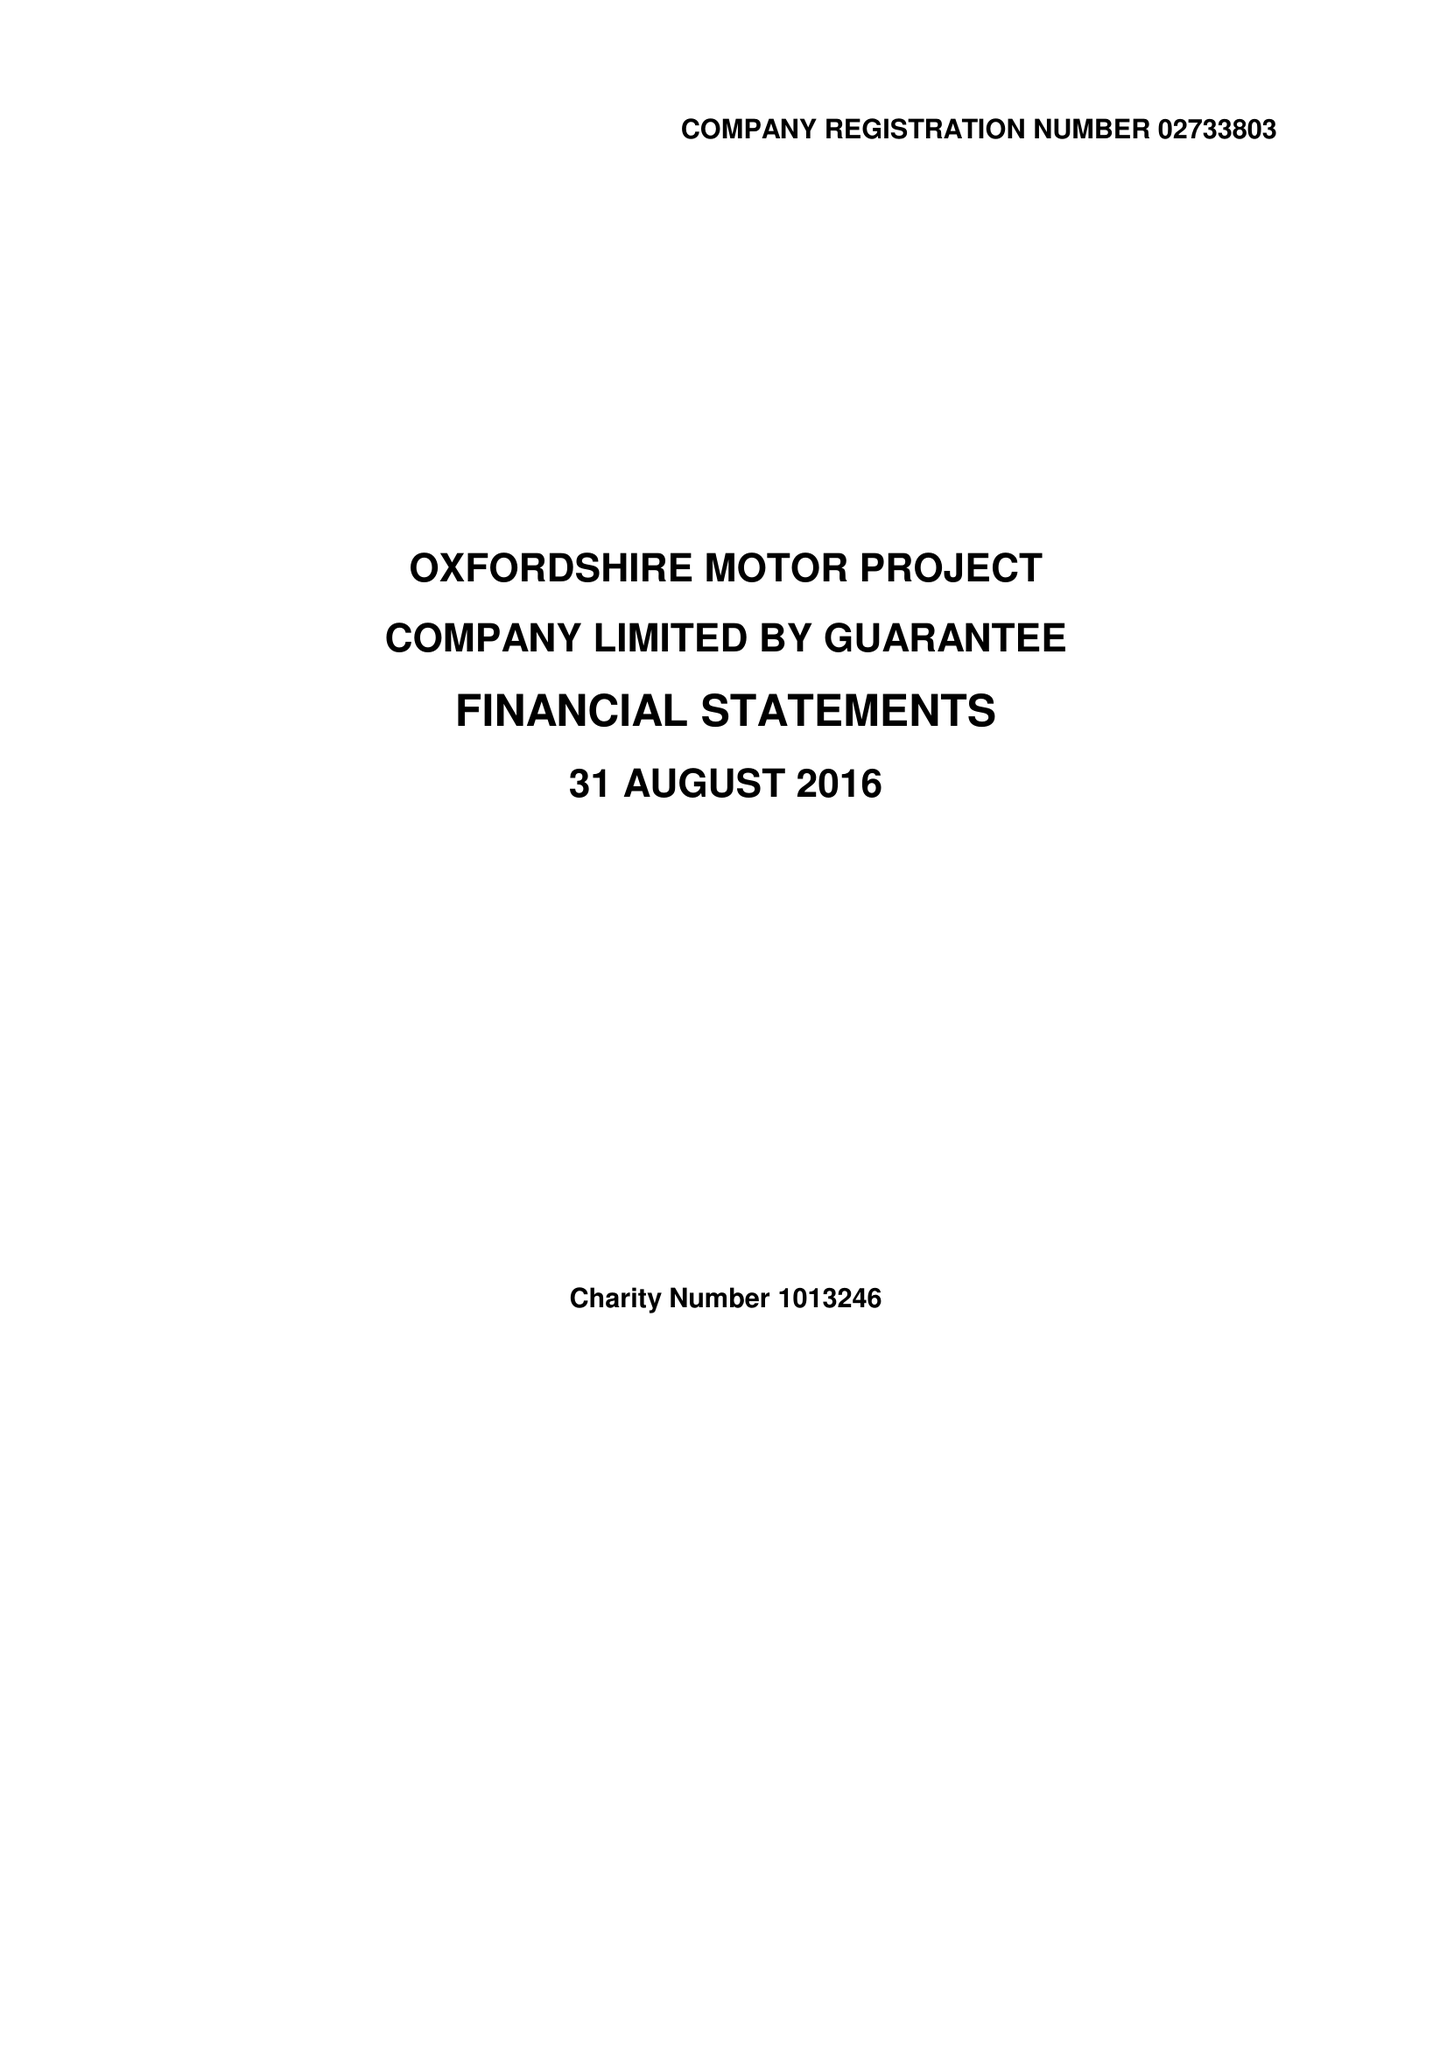What is the value for the report_date?
Answer the question using a single word or phrase. 2016-08-31 